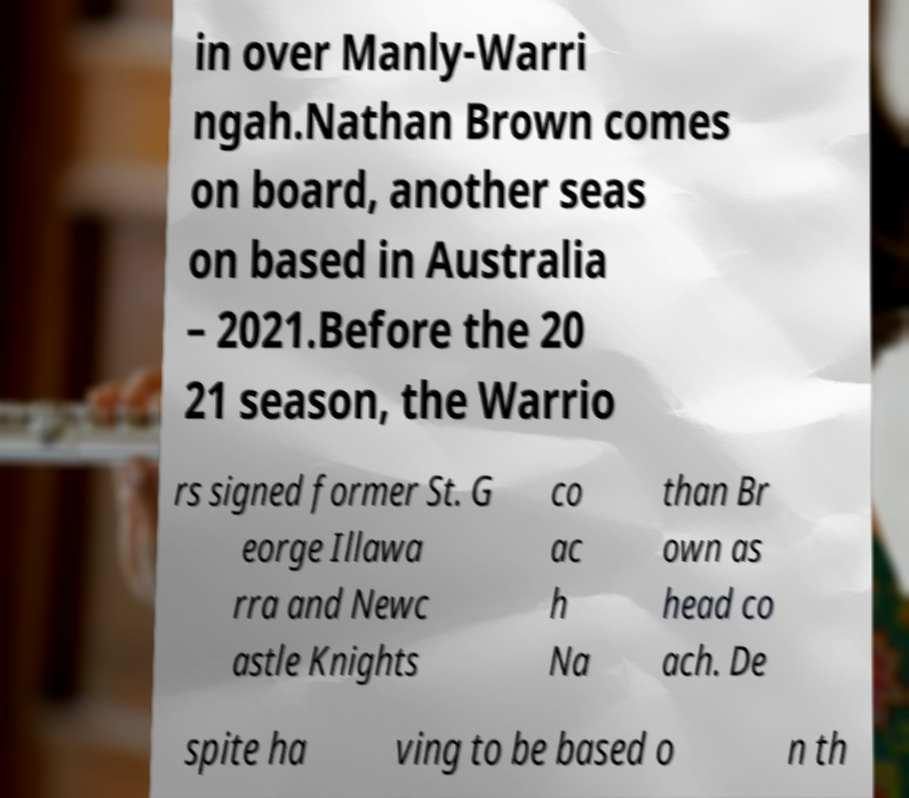Could you extract and type out the text from this image? in over Manly-Warri ngah.Nathan Brown comes on board, another seas on based in Australia – 2021.Before the 20 21 season, the Warrio rs signed former St. G eorge Illawa rra and Newc astle Knights co ac h Na than Br own as head co ach. De spite ha ving to be based o n th 